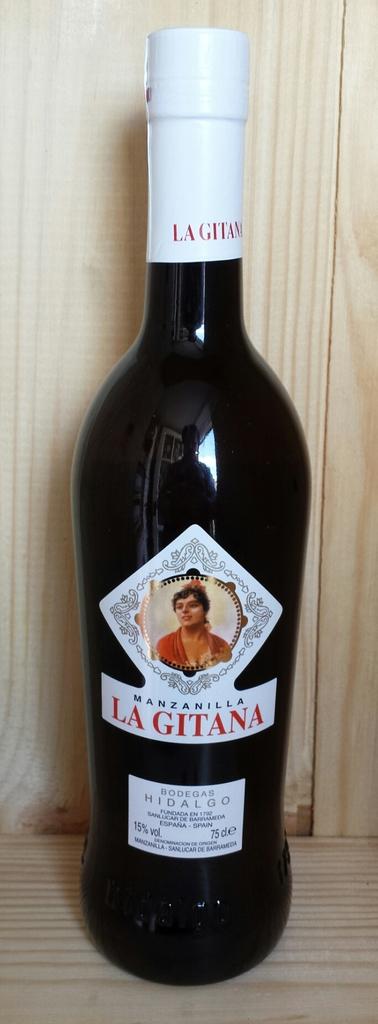What is the name of this drink?
Provide a succinct answer. La gitana. What is the alcohol percentage?
Give a very brief answer. 15. 